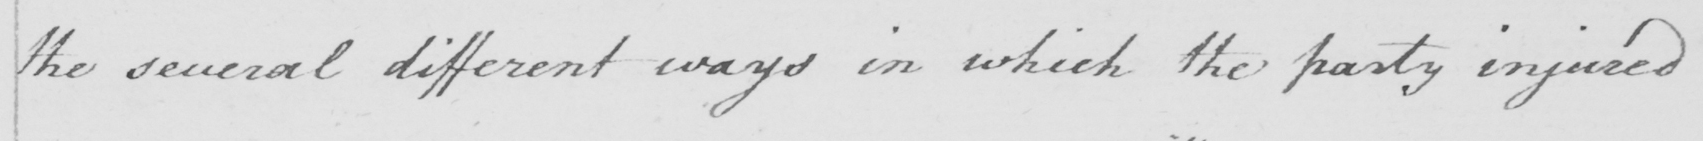What is written in this line of handwriting? the several different ways in which the party injured 